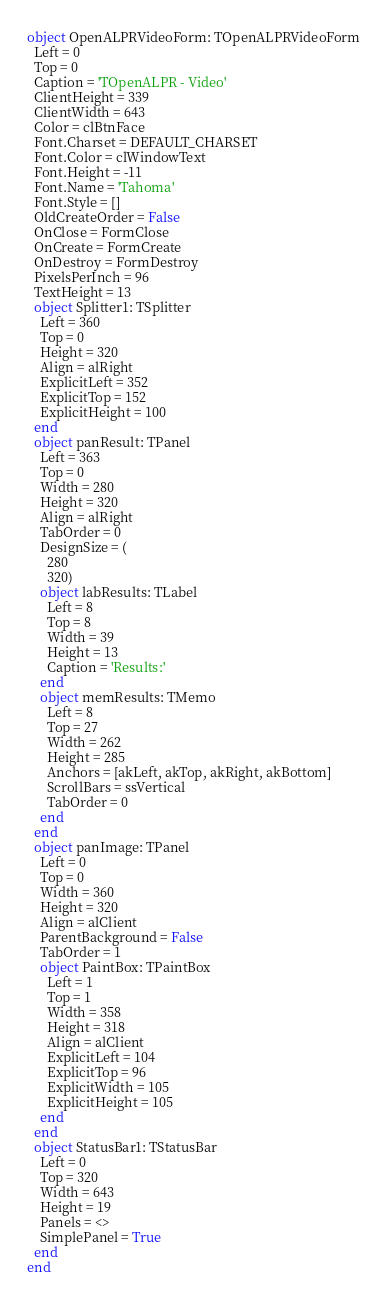Convert code to text. <code><loc_0><loc_0><loc_500><loc_500><_Pascal_>object OpenALPRVideoForm: TOpenALPRVideoForm
  Left = 0
  Top = 0
  Caption = 'TOpenALPR - Video'
  ClientHeight = 339
  ClientWidth = 643
  Color = clBtnFace
  Font.Charset = DEFAULT_CHARSET
  Font.Color = clWindowText
  Font.Height = -11
  Font.Name = 'Tahoma'
  Font.Style = []
  OldCreateOrder = False
  OnClose = FormClose
  OnCreate = FormCreate
  OnDestroy = FormDestroy
  PixelsPerInch = 96
  TextHeight = 13
  object Splitter1: TSplitter
    Left = 360
    Top = 0
    Height = 320
    Align = alRight
    ExplicitLeft = 352
    ExplicitTop = 152
    ExplicitHeight = 100
  end
  object panResult: TPanel
    Left = 363
    Top = 0
    Width = 280
    Height = 320
    Align = alRight
    TabOrder = 0
    DesignSize = (
      280
      320)
    object labResults: TLabel
      Left = 8
      Top = 8
      Width = 39
      Height = 13
      Caption = 'Results:'
    end
    object memResults: TMemo
      Left = 8
      Top = 27
      Width = 262
      Height = 285
      Anchors = [akLeft, akTop, akRight, akBottom]
      ScrollBars = ssVertical
      TabOrder = 0
    end
  end
  object panImage: TPanel
    Left = 0
    Top = 0
    Width = 360
    Height = 320
    Align = alClient
    ParentBackground = False
    TabOrder = 1
    object PaintBox: TPaintBox
      Left = 1
      Top = 1
      Width = 358
      Height = 318
      Align = alClient
      ExplicitLeft = 104
      ExplicitTop = 96
      ExplicitWidth = 105
      ExplicitHeight = 105
    end
  end
  object StatusBar1: TStatusBar
    Left = 0
    Top = 320
    Width = 643
    Height = 19
    Panels = <>
    SimplePanel = True
  end
end
</code> 